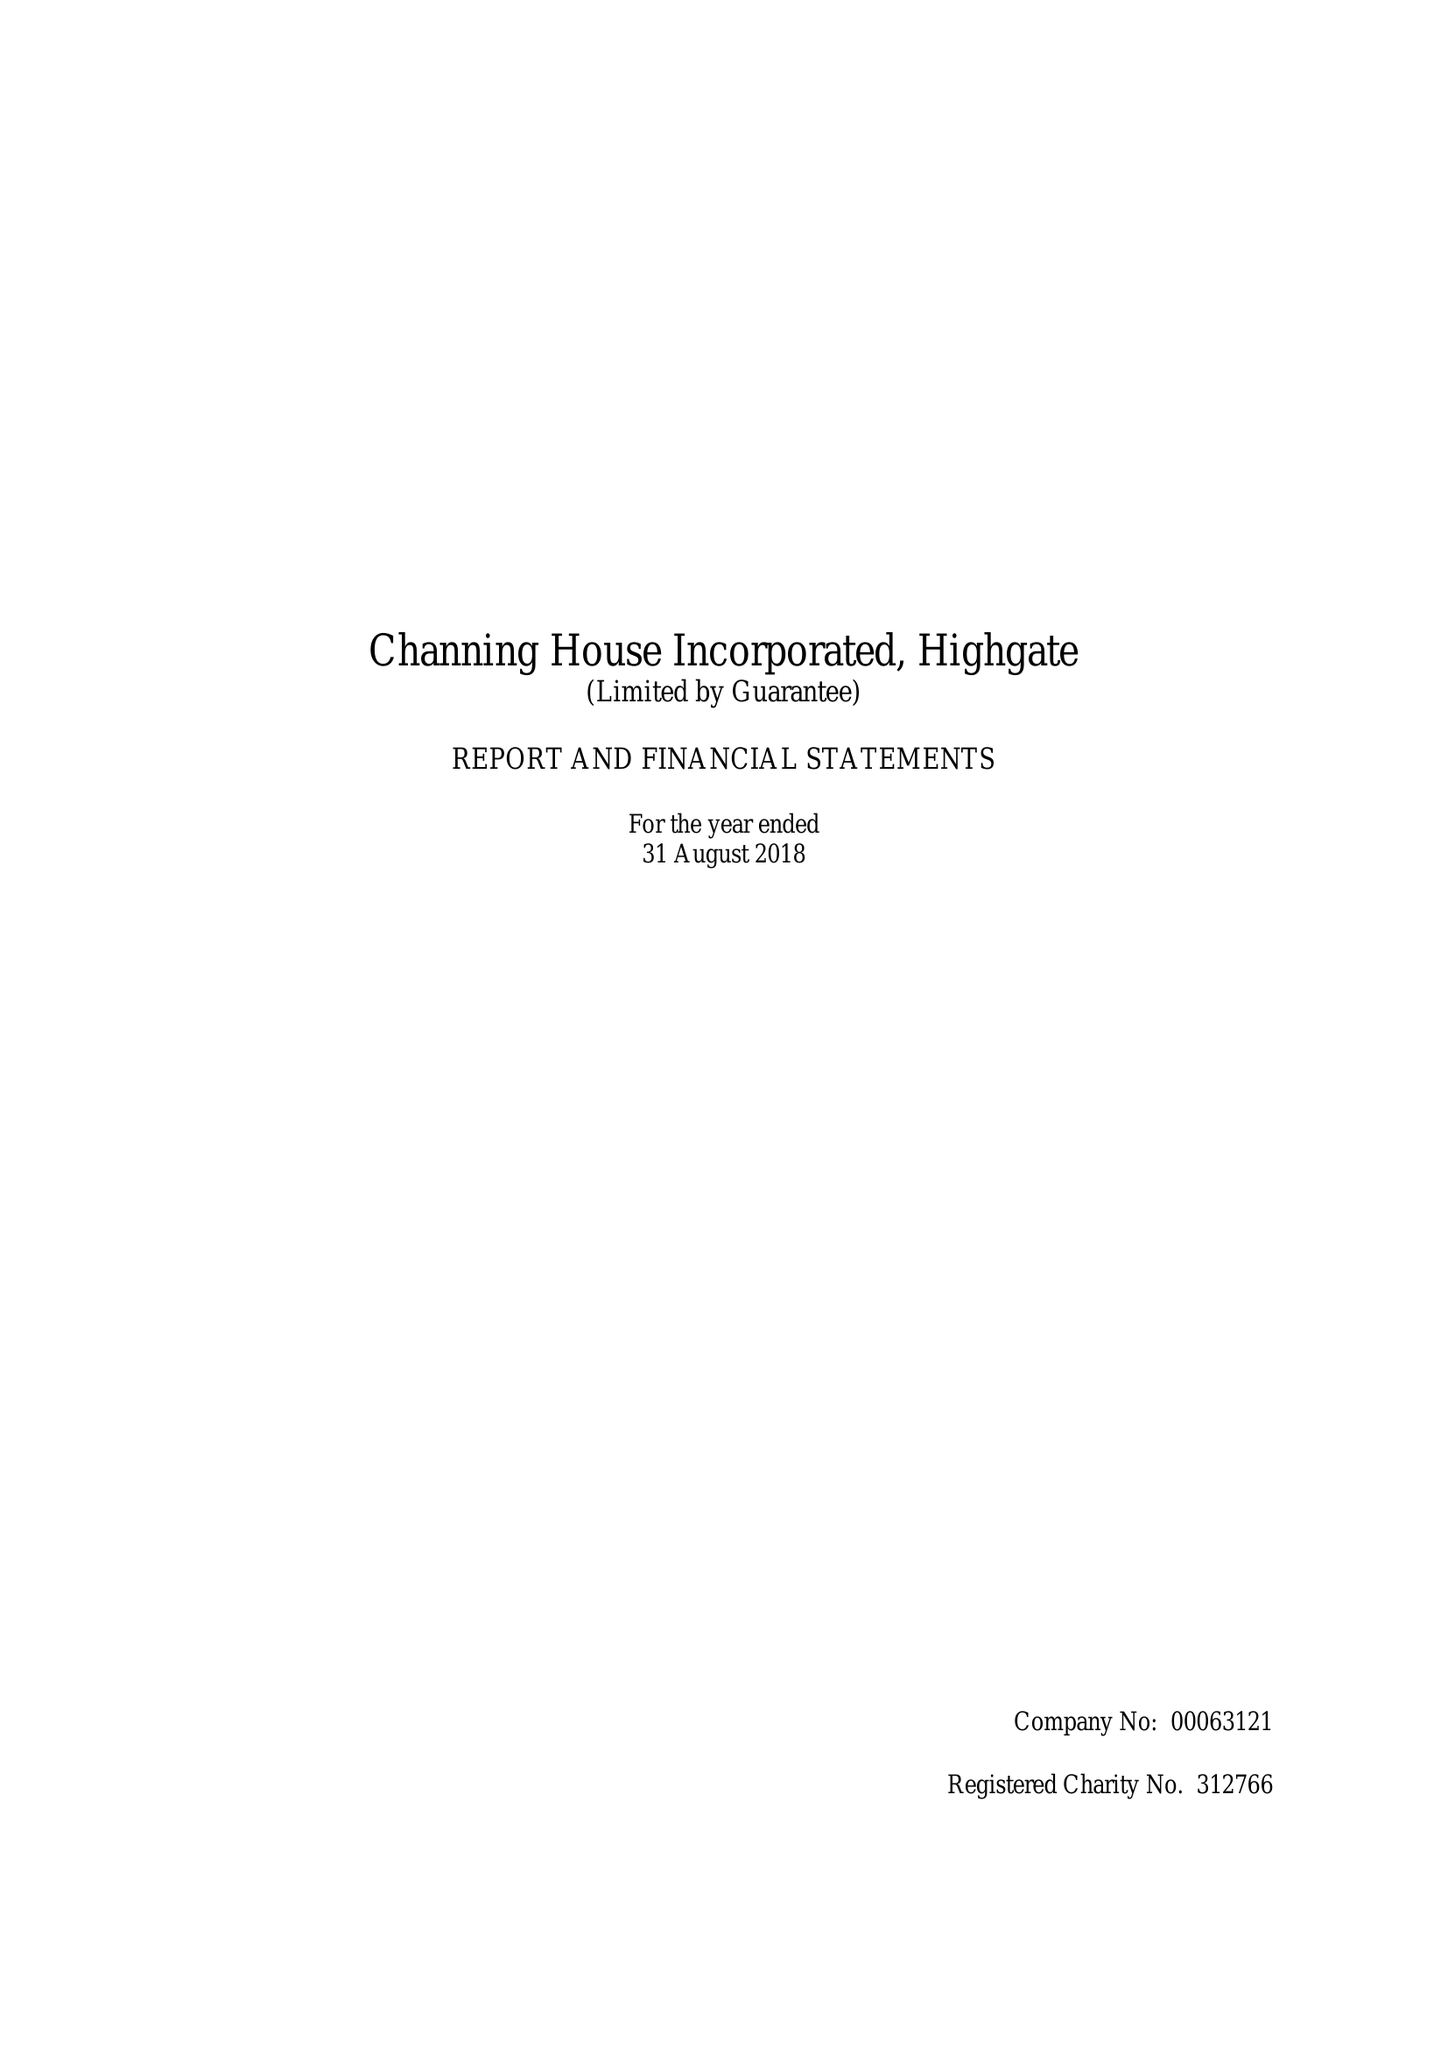What is the value for the report_date?
Answer the question using a single word or phrase. 2018-08-31 